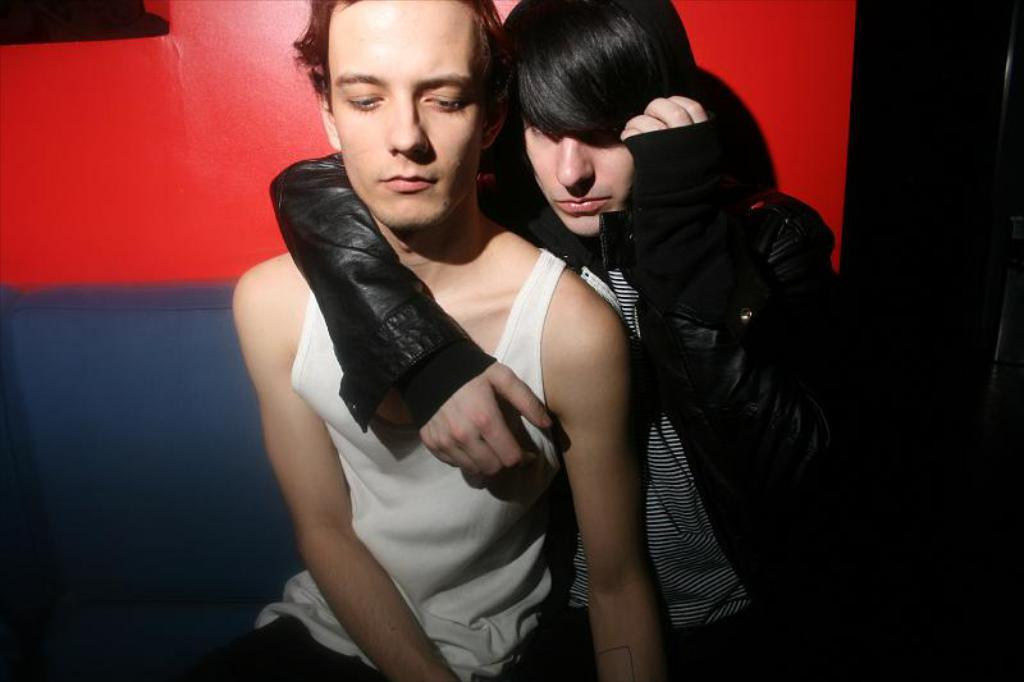How many people are in the image? There are two people in the image. What are the two people doing in the image? The two people are sitting on a sofa. What can be seen in the background of the image? There is a wall in the image. How many geese are present in the image? There are no geese present in the image. What is the value of the sofa in the image? The value of the sofa cannot be determined from the image alone. 